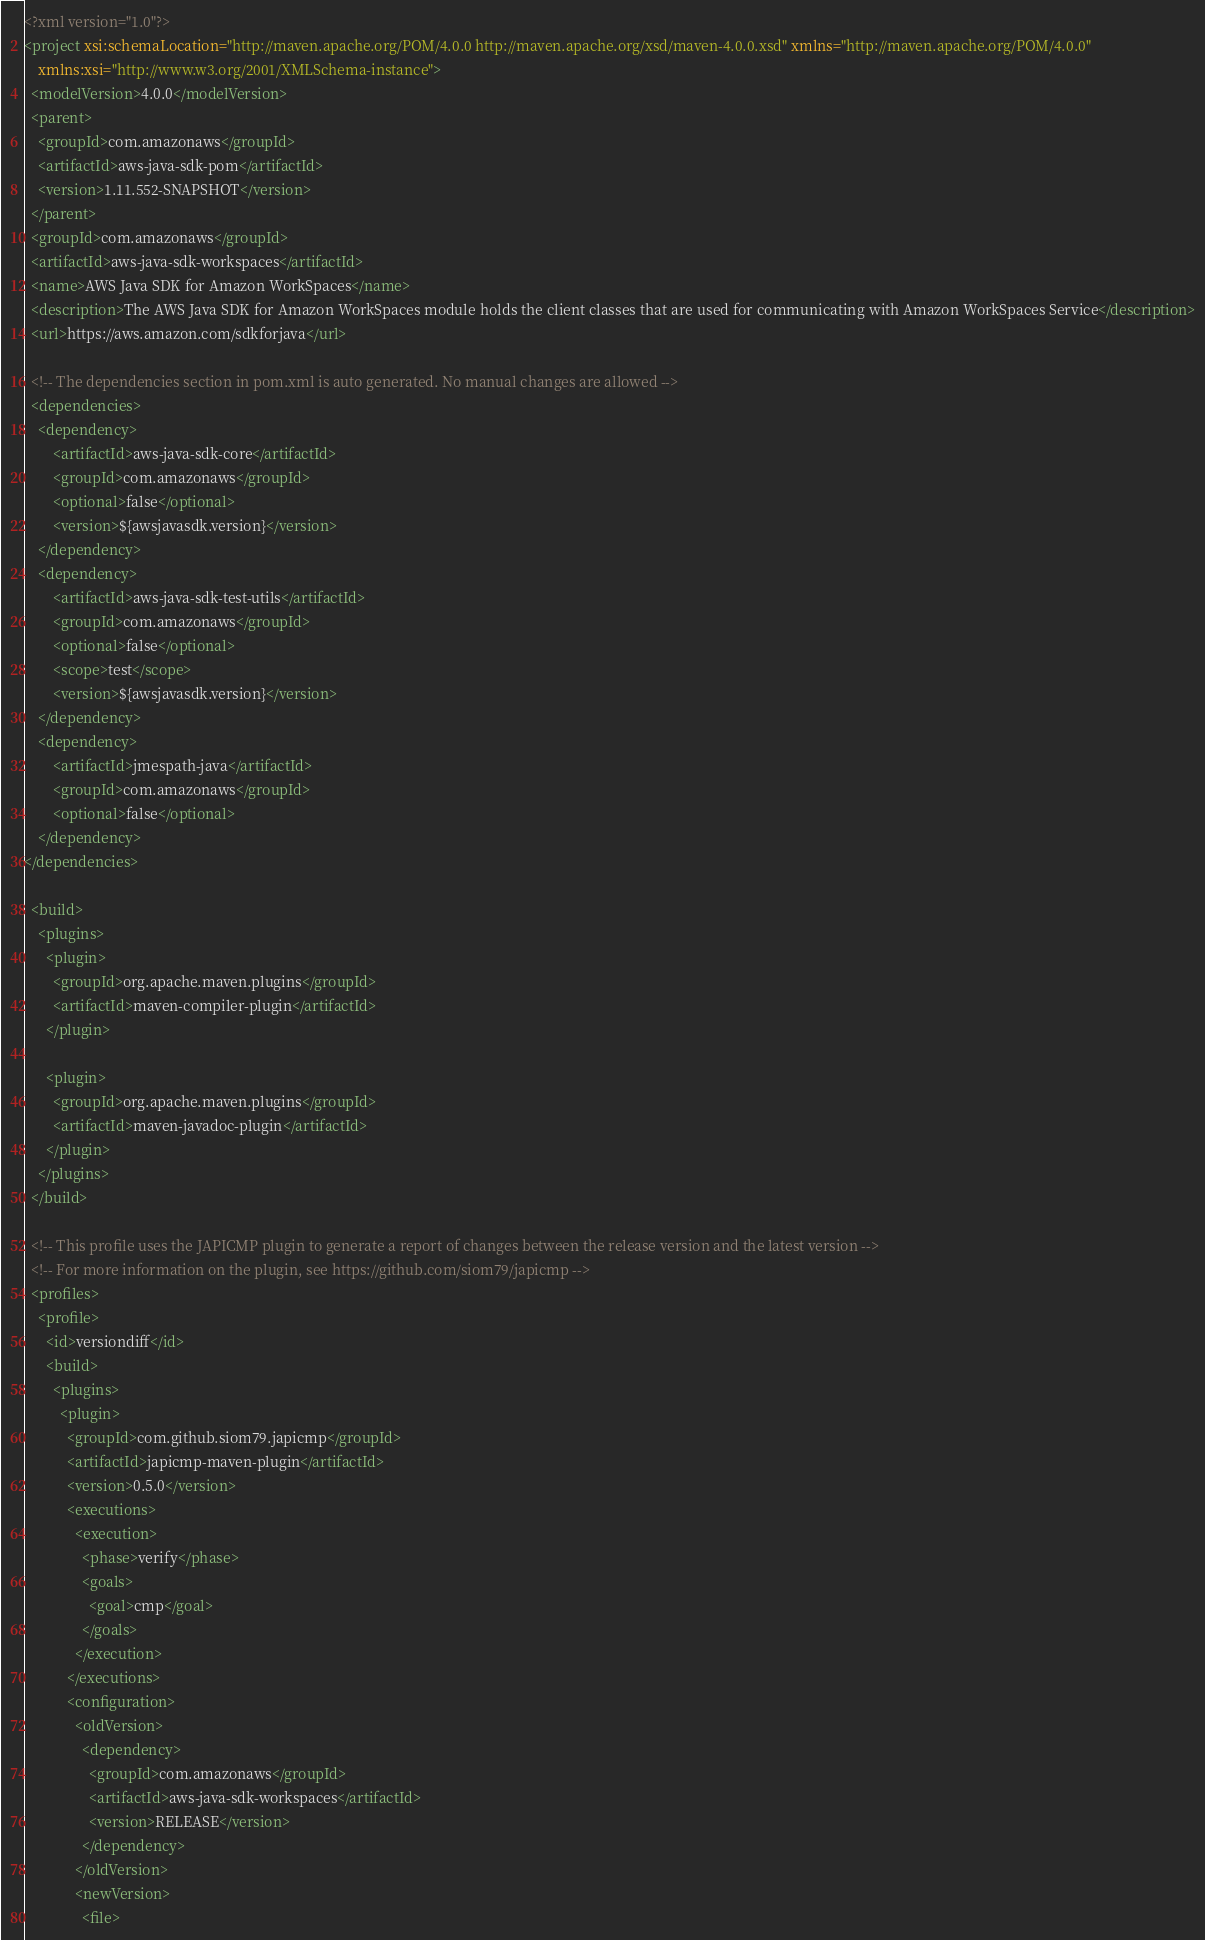<code> <loc_0><loc_0><loc_500><loc_500><_XML_><?xml version="1.0"?>
<project xsi:schemaLocation="http://maven.apache.org/POM/4.0.0 http://maven.apache.org/xsd/maven-4.0.0.xsd" xmlns="http://maven.apache.org/POM/4.0.0"
    xmlns:xsi="http://www.w3.org/2001/XMLSchema-instance">
  <modelVersion>4.0.0</modelVersion>
  <parent>
    <groupId>com.amazonaws</groupId>
    <artifactId>aws-java-sdk-pom</artifactId>
    <version>1.11.552-SNAPSHOT</version>
  </parent>
  <groupId>com.amazonaws</groupId>
  <artifactId>aws-java-sdk-workspaces</artifactId>
  <name>AWS Java SDK for Amazon WorkSpaces</name>
  <description>The AWS Java SDK for Amazon WorkSpaces module holds the client classes that are used for communicating with Amazon WorkSpaces Service</description>
  <url>https://aws.amazon.com/sdkforjava</url>

  <!-- The dependencies section in pom.xml is auto generated. No manual changes are allowed -->
  <dependencies>
    <dependency>
        <artifactId>aws-java-sdk-core</artifactId>
        <groupId>com.amazonaws</groupId>
        <optional>false</optional>
        <version>${awsjavasdk.version}</version>
    </dependency>
    <dependency>
        <artifactId>aws-java-sdk-test-utils</artifactId>
        <groupId>com.amazonaws</groupId>
        <optional>false</optional>
        <scope>test</scope>
        <version>${awsjavasdk.version}</version>
    </dependency>
    <dependency>
        <artifactId>jmespath-java</artifactId>
        <groupId>com.amazonaws</groupId>
        <optional>false</optional>
    </dependency>
</dependencies>

  <build>
    <plugins>
      <plugin>
        <groupId>org.apache.maven.plugins</groupId>
        <artifactId>maven-compiler-plugin</artifactId>
      </plugin>

      <plugin>
        <groupId>org.apache.maven.plugins</groupId>
        <artifactId>maven-javadoc-plugin</artifactId>
      </plugin>
    </plugins>
  </build>

  <!-- This profile uses the JAPICMP plugin to generate a report of changes between the release version and the latest version -->
  <!-- For more information on the plugin, see https://github.com/siom79/japicmp -->
  <profiles>
    <profile>
      <id>versiondiff</id>
      <build>
        <plugins>
          <plugin>
            <groupId>com.github.siom79.japicmp</groupId>
            <artifactId>japicmp-maven-plugin</artifactId>
            <version>0.5.0</version>
            <executions>
              <execution>
                <phase>verify</phase>
                <goals>
                  <goal>cmp</goal>
                </goals>
              </execution>
            </executions>
            <configuration>
              <oldVersion>
                <dependency>
                  <groupId>com.amazonaws</groupId>
                  <artifactId>aws-java-sdk-workspaces</artifactId>
                  <version>RELEASE</version>
                </dependency>
              </oldVersion>
              <newVersion>
                <file></code> 